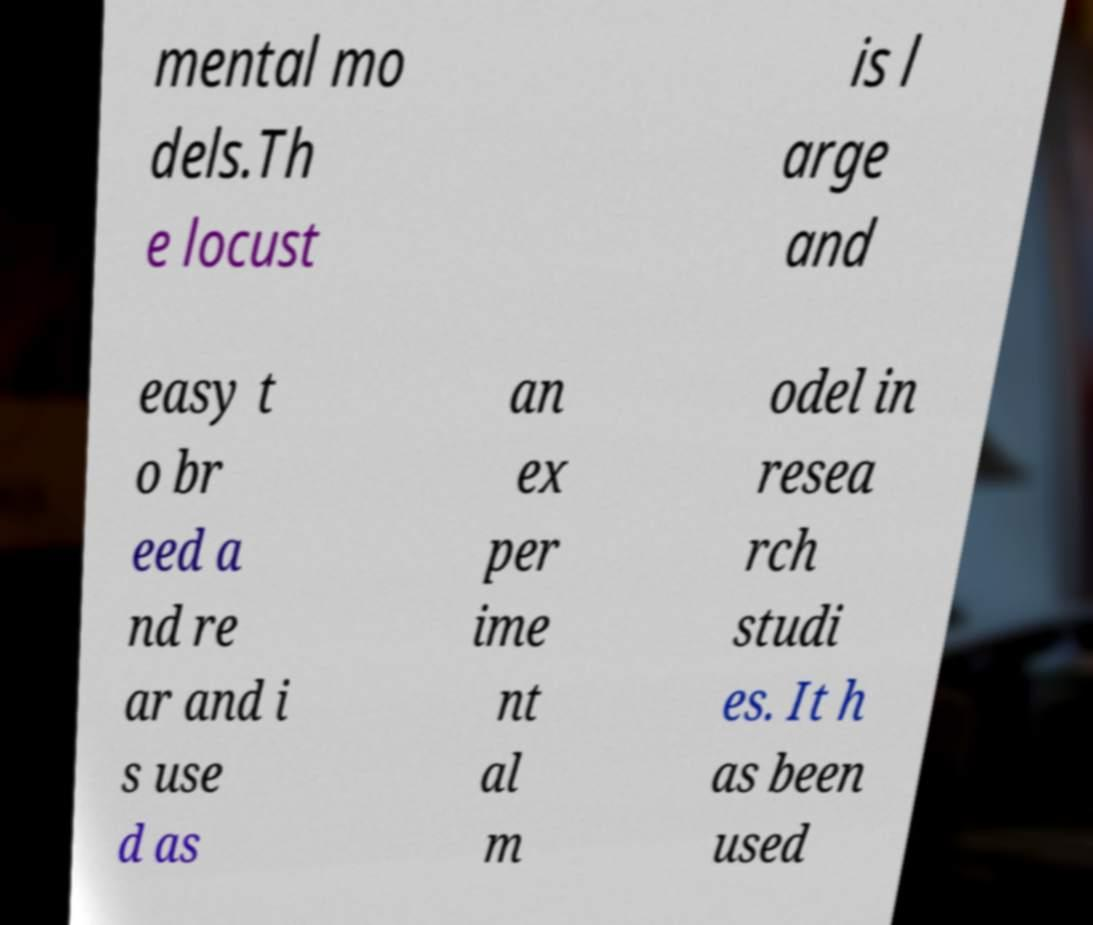What messages or text are displayed in this image? I need them in a readable, typed format. mental mo dels.Th e locust is l arge and easy t o br eed a nd re ar and i s use d as an ex per ime nt al m odel in resea rch studi es. It h as been used 